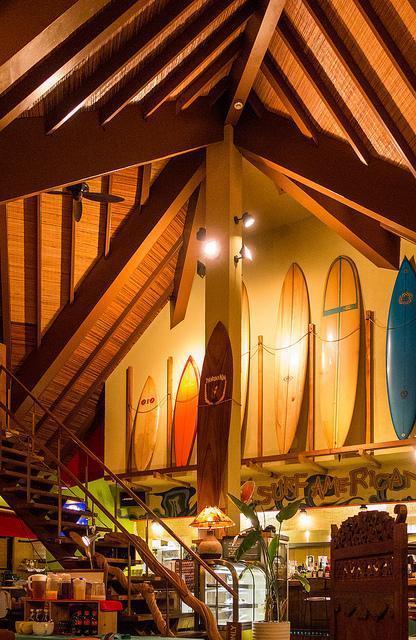How many surfboards can be seen?
Give a very brief answer. 4. How many potted plants are there?
Give a very brief answer. 1. How many people are in this picture?
Give a very brief answer. 0. 